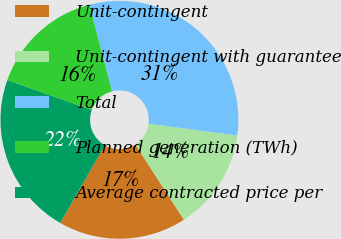<chart> <loc_0><loc_0><loc_500><loc_500><pie_chart><fcel>Unit-contingent<fcel>Unit-contingent with guarantee<fcel>Total<fcel>Planned generation (TWh)<fcel>Average contracted price per<nl><fcel>17.4%<fcel>13.78%<fcel>31.18%<fcel>15.52%<fcel>22.12%<nl></chart> 